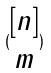Convert formula to latex. <formula><loc_0><loc_0><loc_500><loc_500>( \begin{matrix} [ n ] \\ m \end{matrix} )</formula> 